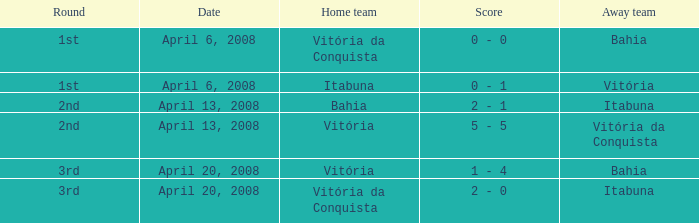Which team hosted the match on april 13, 2008, with itabuna as the visiting team? Bahia. 